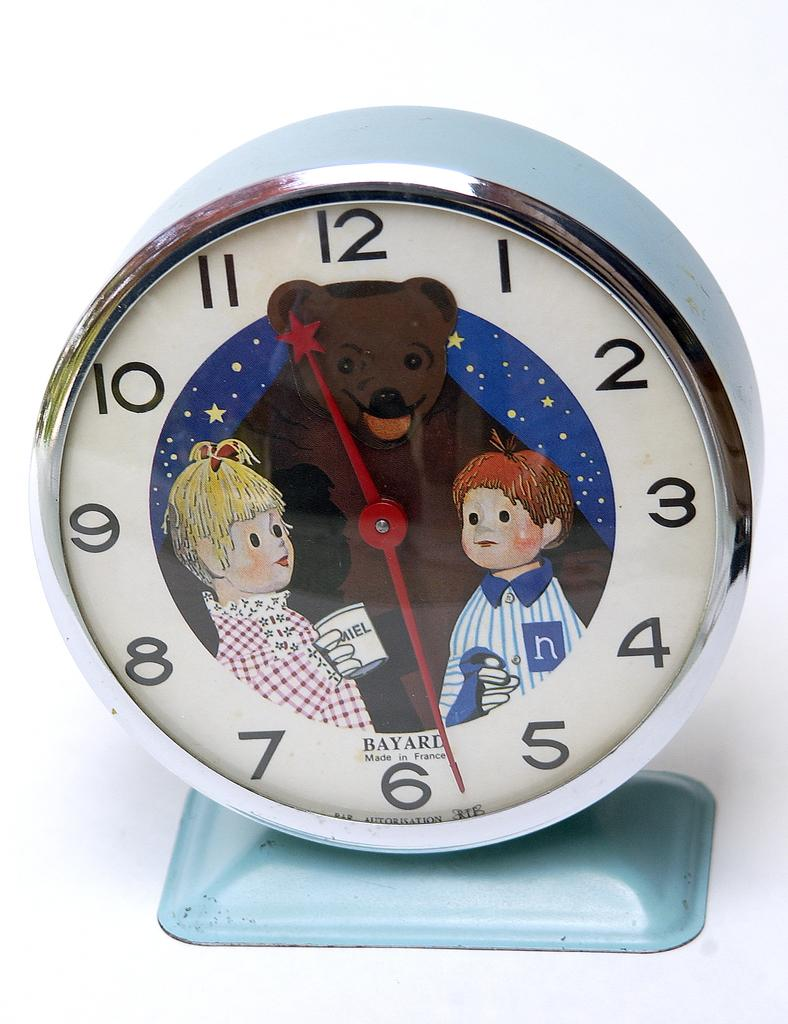<image>
Offer a succinct explanation of the picture presented. a Bayard Clock Made in France with a bear and two kids 